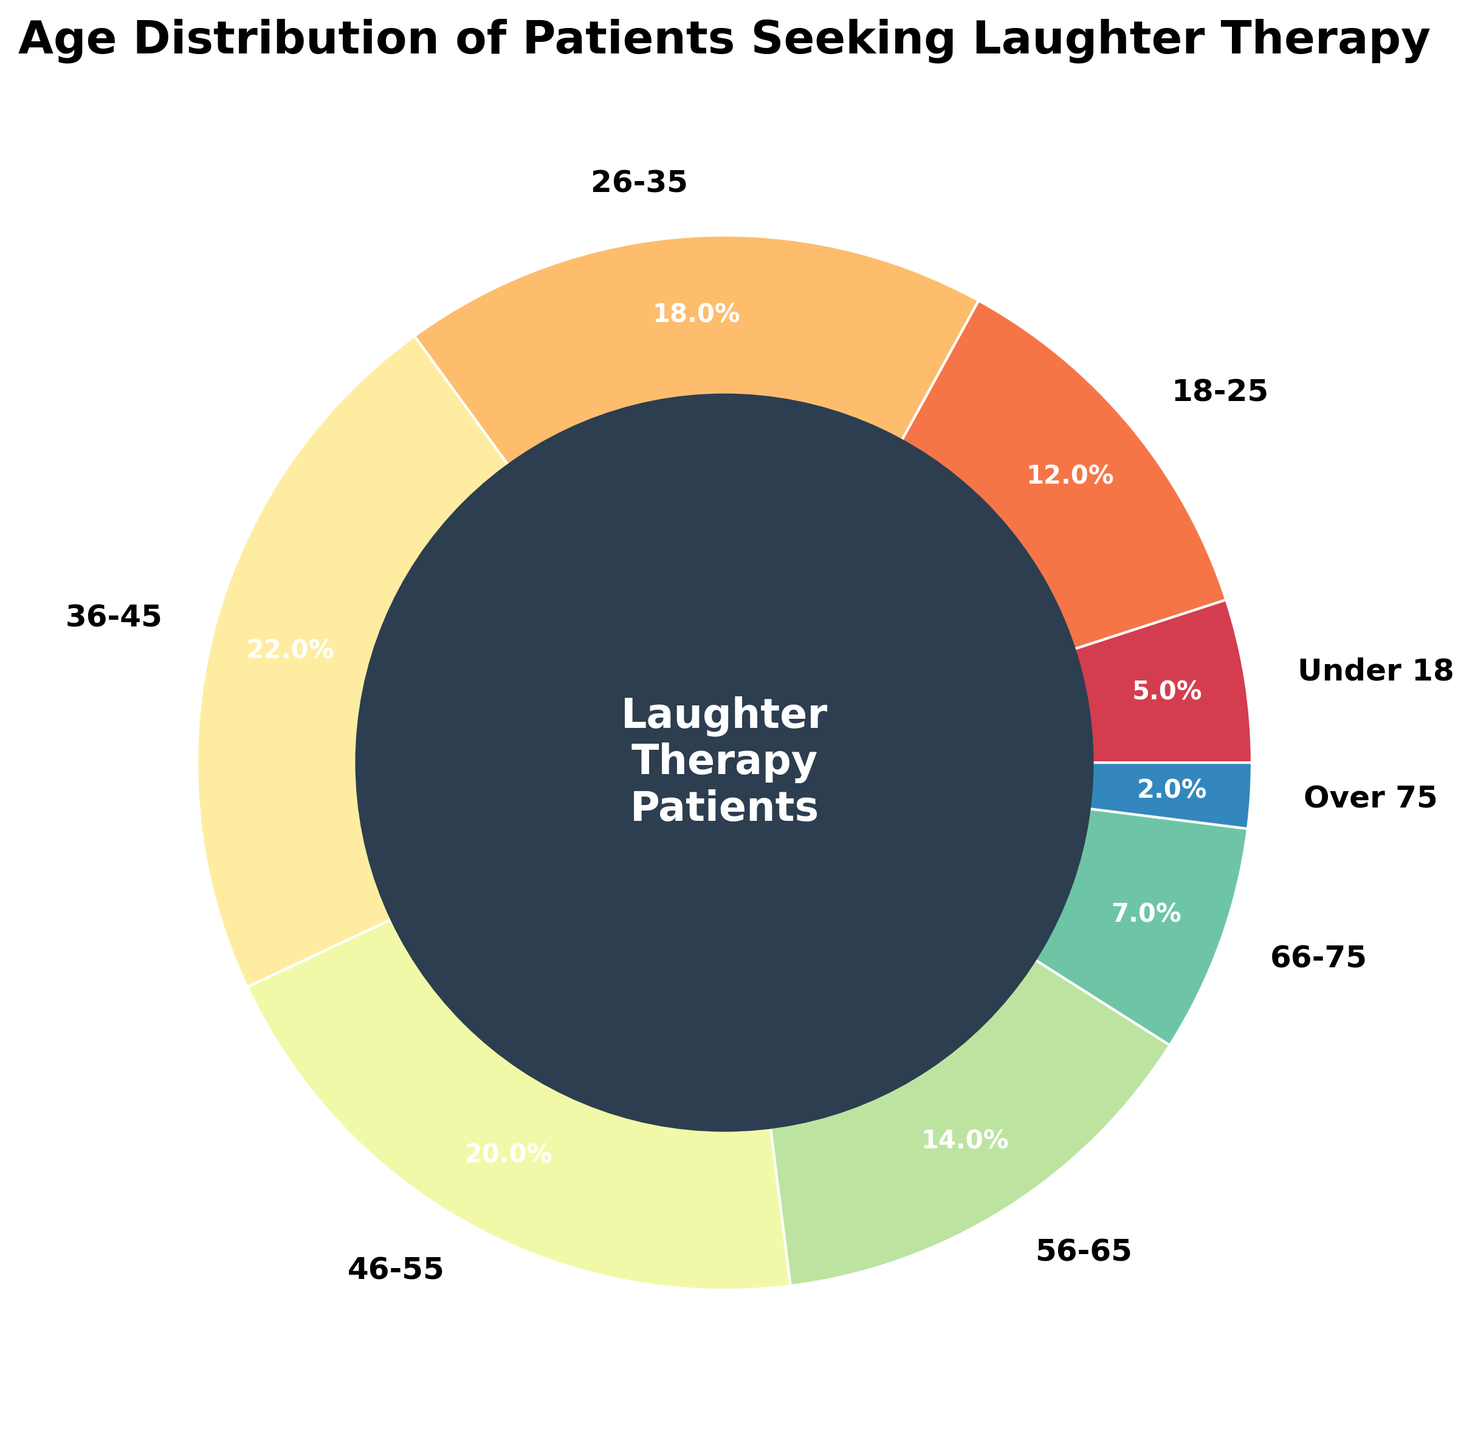What's the largest age group of patients seeking laughter therapy? The pie chart shows distinct age groups and their corresponding percentages. The group with the largest percentage is 36-45 with 22%.
Answer: 36-45 What's the difference in the percentage of patients between the age groups 18-25 and 26-35? According to the pie chart, the percentage for the 18-25 age group is 12%, and for the 26-35 age group, it is 18%. The difference is calculated as 18% - 12%.
Answer: 6% Which age group has the least percentage of patients? By examining the pie chart, the smallest segment corresponds to the Over 75 age group, which comprises 2% of the total.
Answer: Over 75 How many age groups have a percentage greater than 15%? Checking the percentage values in the pie chart, the age groups 26-35 (18%), 36-45 (22%), and 46-55 (20%) are the only groups over 15%. There are 3 such groups.
Answer: 3 What percentage of patients are aged between 46 to 65? The age groups within 46-65 are 46-55 with 20% and 56-65 with 14%. Adding these two together gives 20% + 14%.
Answer: 34% Compare the percentage of patients under 18 with those over 75. Which one is greater? The pie chart shows that the Under 18 age group has 5%, and the Over 75 age group has 2%. Comparing these, 5% is greater than 2%.
Answer: Under 18 What portion of the chart is occupied by patients aged 36 to 55? The relevant age groups are 36-45 and 46-55. Their percentages are 22% and 20%, respectively. Together they make up 22% + 20%.
Answer: 42% What is the average percentage of patients for the age groups under 18, 66-75, and over 75? The percentages for the age groups are 5%, 7%, and 2%. The average is calculated as (5% + 7% + 2%) / 3.
Answer: 4.67% If two age groups have identical percentages, which ones are they? According to the chart, no two age groups have identical percentages as each group has a unique percentage value.
Answer: None 